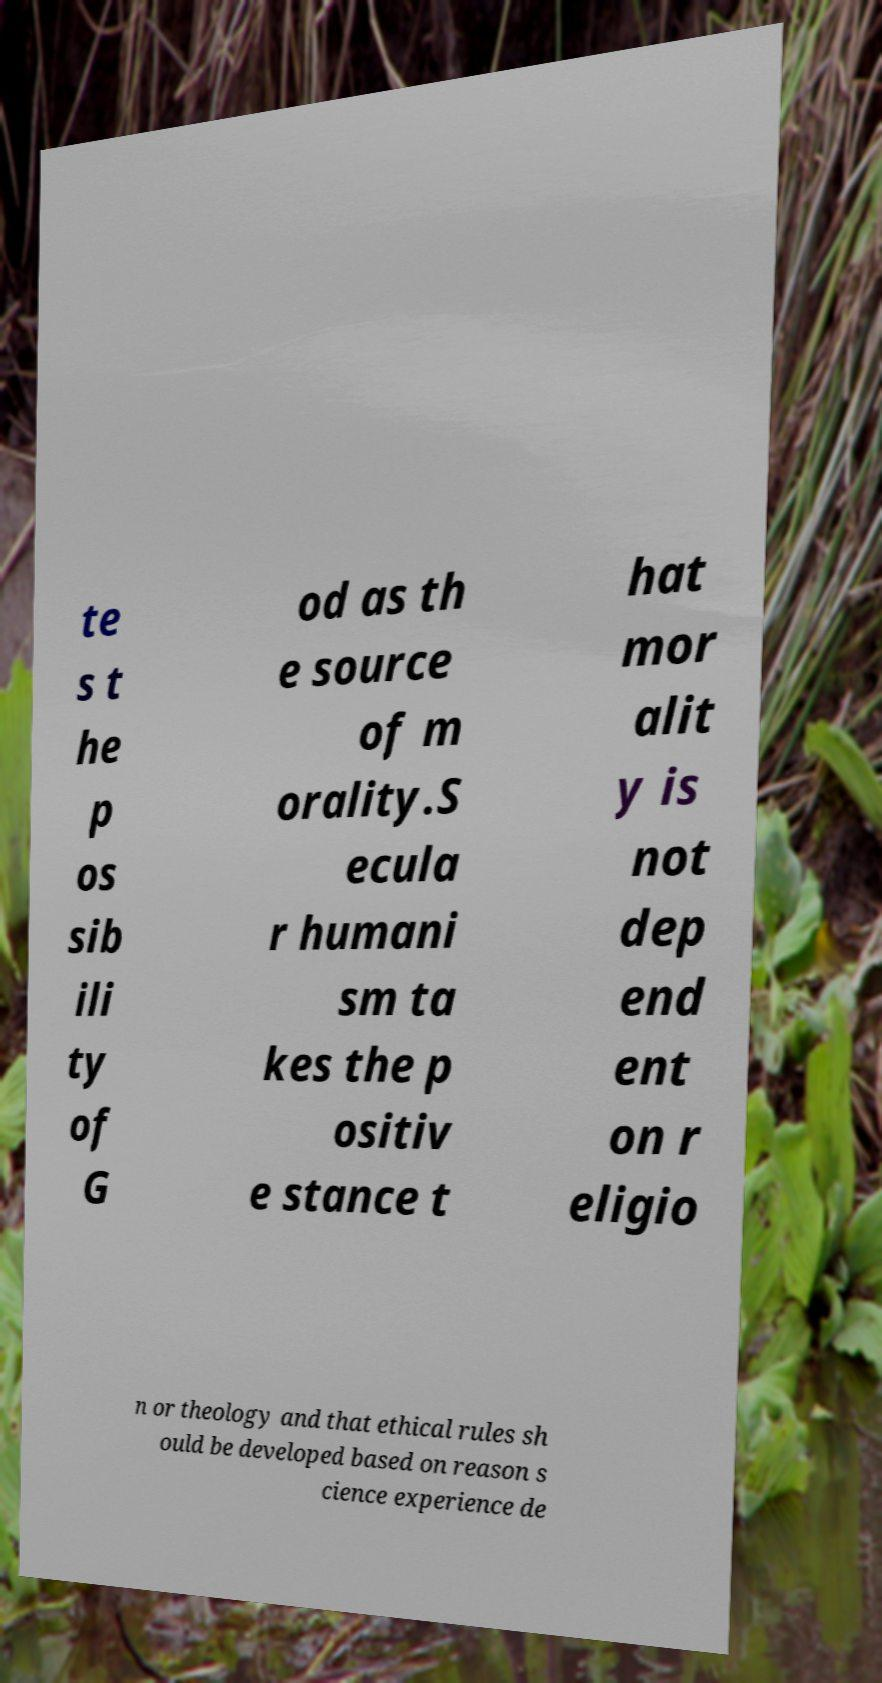There's text embedded in this image that I need extracted. Can you transcribe it verbatim? te s t he p os sib ili ty of G od as th e source of m orality.S ecula r humani sm ta kes the p ositiv e stance t hat mor alit y is not dep end ent on r eligio n or theology and that ethical rules sh ould be developed based on reason s cience experience de 